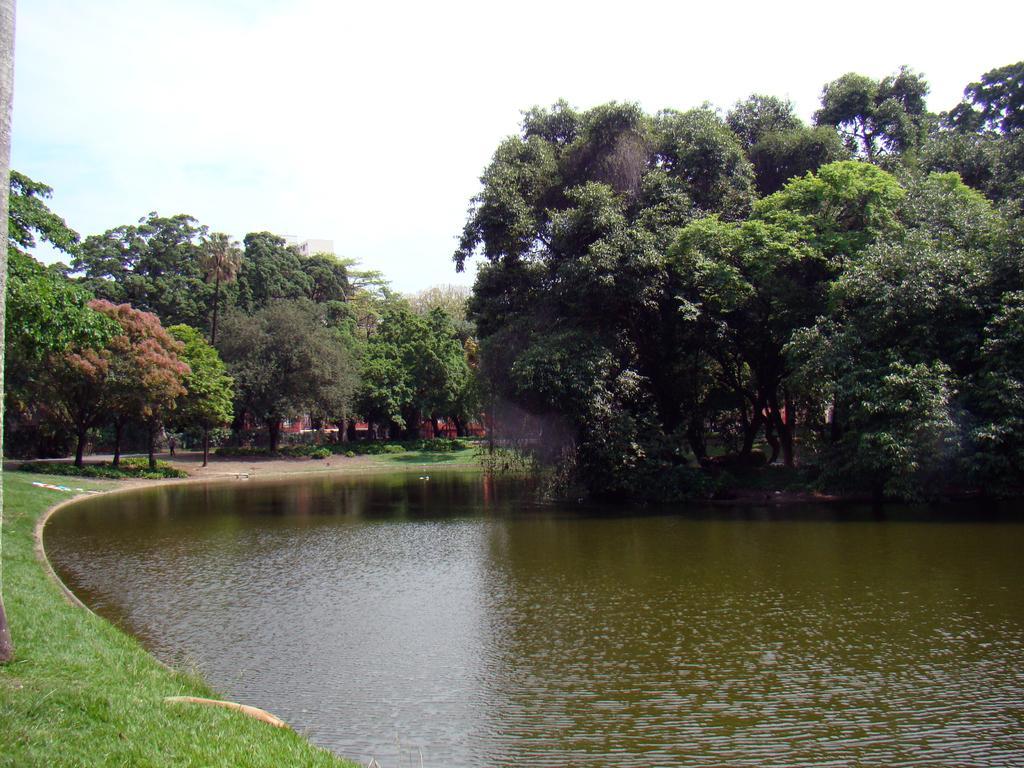Could you give a brief overview of what you see in this image? In this image I see the water over here and I see the green grass. In the background I see the sky which is clear and I see number of trees. 